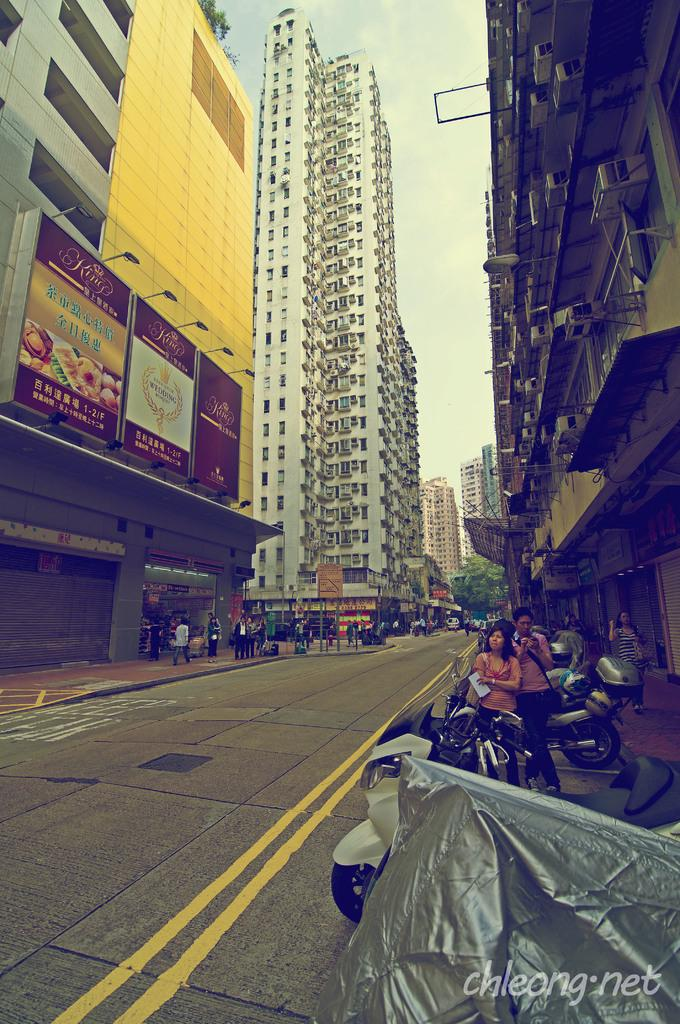How many people can be seen in the image? There are people in the image, but the exact number is not specified. What types of vehicles are present in the image? There are vehicles in the image, but the specific types are not mentioned. What is the purpose of the vehicle cover in the image? The purpose of the vehicle cover is to protect the vehicle from weather or other external factors. What kind of structures are depicted in the image? There are buildings in the image, but their specific types or functions are not described. What is the purpose of the lights in the image? The lights in the image could serve various purposes, such as illuminating the area or signaling information. What are the boards in the image used for? The boards in the image could be used for various purposes, such as advertising or providing information. What type of vegetation is visible in the image? There are trees in the image, but their specific species are not mentioned. What can be seen in the background of the image? The sky is visible in the background of the image. Where is the oven located in the image? There is no oven present in the image. What is the limit of the attention span of the people in the image? The image does not provide information about the attention span of the people in the image. 